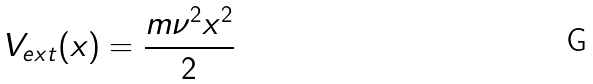Convert formula to latex. <formula><loc_0><loc_0><loc_500><loc_500>V _ { e x t } ( x ) = \frac { m \nu ^ { 2 } x ^ { 2 } } { 2 }</formula> 